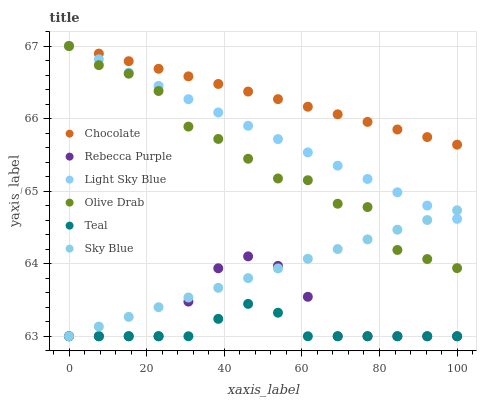Does Teal have the minimum area under the curve?
Answer yes or no. Yes. Does Chocolate have the maximum area under the curve?
Answer yes or no. Yes. Does Light Sky Blue have the minimum area under the curve?
Answer yes or no. No. Does Light Sky Blue have the maximum area under the curve?
Answer yes or no. No. Is Chocolate the smoothest?
Answer yes or no. Yes. Is Olive Drab the roughest?
Answer yes or no. Yes. Is Light Sky Blue the smoothest?
Answer yes or no. No. Is Light Sky Blue the roughest?
Answer yes or no. No. Does Rebecca Purple have the lowest value?
Answer yes or no. Yes. Does Light Sky Blue have the lowest value?
Answer yes or no. No. Does Olive Drab have the highest value?
Answer yes or no. Yes. Does Rebecca Purple have the highest value?
Answer yes or no. No. Is Rebecca Purple less than Chocolate?
Answer yes or no. Yes. Is Olive Drab greater than Teal?
Answer yes or no. Yes. Does Olive Drab intersect Chocolate?
Answer yes or no. Yes. Is Olive Drab less than Chocolate?
Answer yes or no. No. Is Olive Drab greater than Chocolate?
Answer yes or no. No. Does Rebecca Purple intersect Chocolate?
Answer yes or no. No. 